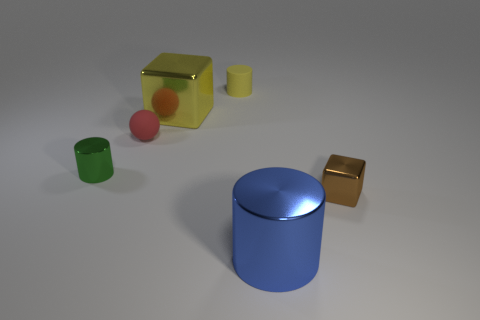Add 1 large cubes. How many objects exist? 7 Subtract all blocks. How many objects are left? 4 Add 4 small metallic things. How many small metallic things exist? 6 Subtract 0 brown cylinders. How many objects are left? 6 Subtract all tiny things. Subtract all big objects. How many objects are left? 0 Add 3 blue metallic things. How many blue metallic things are left? 4 